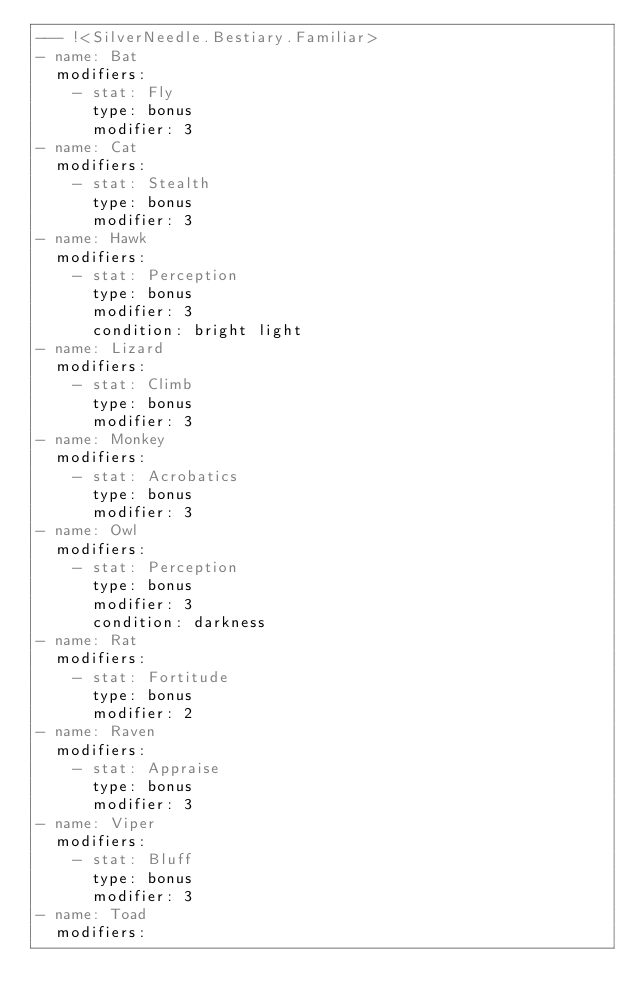<code> <loc_0><loc_0><loc_500><loc_500><_YAML_>--- !<SilverNeedle.Bestiary.Familiar>
- name: Bat
  modifiers:
    - stat: Fly
      type: bonus
      modifier: 3
- name: Cat
  modifiers:
    - stat: Stealth
      type: bonus
      modifier: 3
- name: Hawk
  modifiers:
    - stat: Perception
      type: bonus
      modifier: 3
      condition: bright light
- name: Lizard
  modifiers:
    - stat: Climb
      type: bonus
      modifier: 3
- name: Monkey
  modifiers:
    - stat: Acrobatics
      type: bonus
      modifier: 3
- name: Owl
  modifiers:
    - stat: Perception
      type: bonus
      modifier: 3
      condition: darkness
- name: Rat
  modifiers:
    - stat: Fortitude
      type: bonus
      modifier: 2
- name: Raven
  modifiers:
    - stat: Appraise
      type: bonus
      modifier: 3
- name: Viper
  modifiers:
    - stat: Bluff
      type: bonus
      modifier: 3
- name: Toad
  modifiers:</code> 